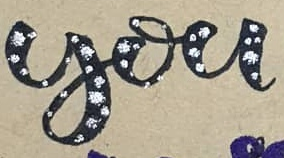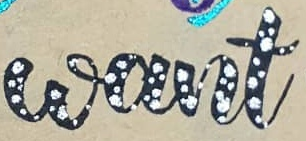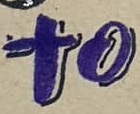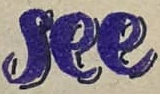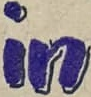What words are shown in these images in order, separated by a semicolon? you; want; to; see; in 